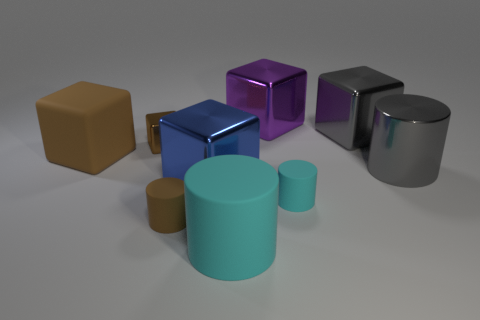Subtract all green cubes. How many cyan cylinders are left? 2 Subtract all brown cubes. How many cubes are left? 3 Add 1 purple shiny blocks. How many objects exist? 10 Subtract all blocks. How many objects are left? 4 Subtract all gray cylinders. How many cylinders are left? 3 Subtract 2 cylinders. How many cylinders are left? 2 Add 8 large gray cubes. How many large gray cubes are left? 9 Add 8 small brown things. How many small brown things exist? 10 Subtract 0 blue cylinders. How many objects are left? 9 Subtract all blue cubes. Subtract all green spheres. How many cubes are left? 4 